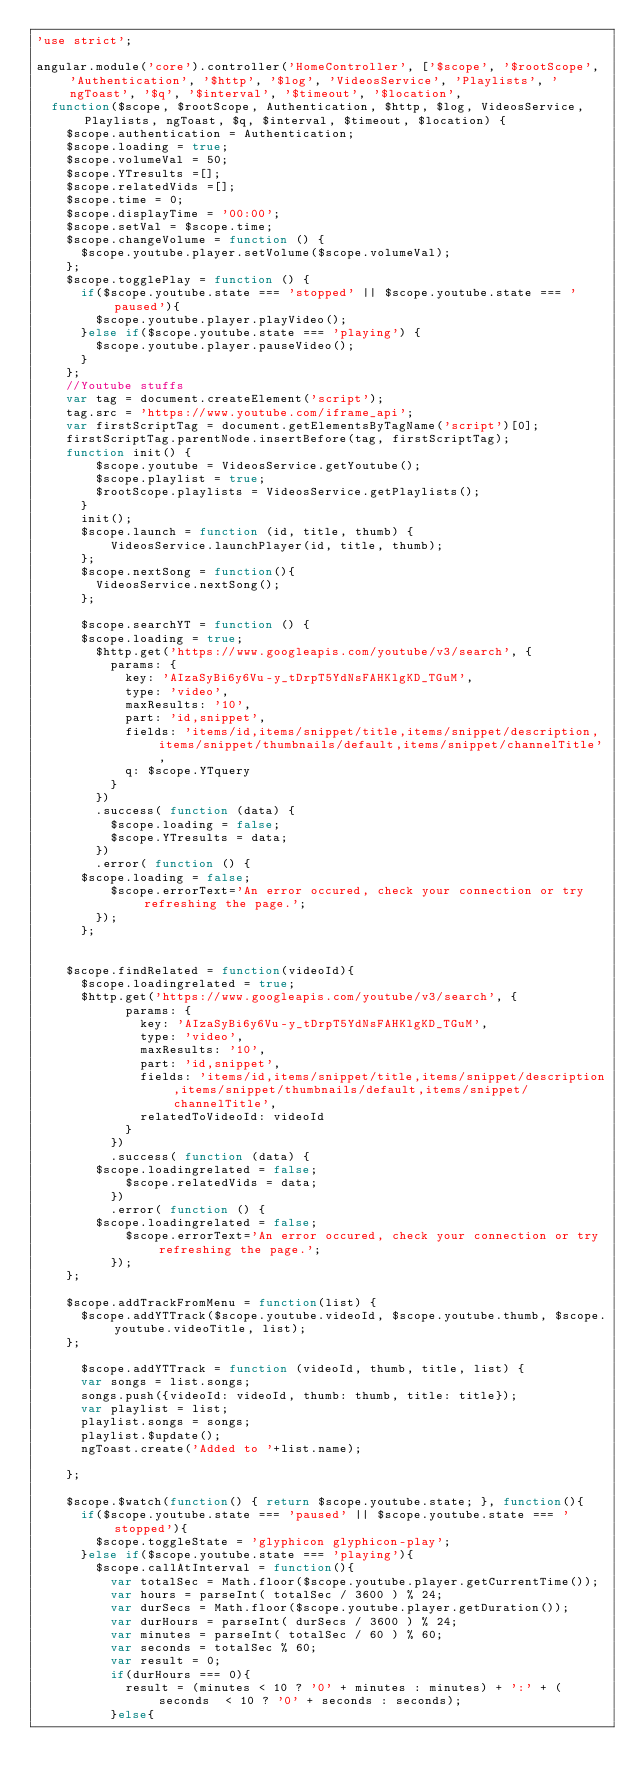<code> <loc_0><loc_0><loc_500><loc_500><_JavaScript_>'use strict';

angular.module('core').controller('HomeController', ['$scope', '$rootScope', 'Authentication', '$http', '$log', 'VideosService', 'Playlists', 'ngToast', '$q', '$interval', '$timeout', '$location',
	function($scope, $rootScope, Authentication, $http, $log, VideosService, Playlists, ngToast, $q, $interval, $timeout, $location) {
		$scope.authentication = Authentication;
		$scope.loading = true;
		$scope.volumeVal = 50;
		$scope.YTresults =[];
		$scope.relatedVids =[];
		$scope.time = 0;
		$scope.displayTime = '00:00';
		$scope.setVal = $scope.time;
		$scope.changeVolume = function () {
			$scope.youtube.player.setVolume($scope.volumeVal);
		};
		$scope.togglePlay = function () {
			if($scope.youtube.state === 'stopped' || $scope.youtube.state === 'paused'){
				$scope.youtube.player.playVideo();
			}else if($scope.youtube.state === 'playing') {
				$scope.youtube.player.pauseVideo();
			}
		};
		//Youtube stuffs
		var tag = document.createElement('script');
		tag.src = 'https://www.youtube.com/iframe_api';
		var firstScriptTag = document.getElementsByTagName('script')[0];
		firstScriptTag.parentNode.insertBefore(tag, firstScriptTag);
		function init() {
	      $scope.youtube = VideosService.getYoutube();
	      $scope.playlist = true;
	      $rootScope.playlists = VideosService.getPlaylists();
	    }
	    init();
	    $scope.launch = function (id, title, thumb) {
	      	VideosService.launchPlayer(id, title, thumb);
	    };
	    $scope.nextSong = function(){
	    	VideosService.nextSong();
	    };

	    $scope.searchYT = function () {
			$scope.loading = true;
	    	$http.get('https://www.googleapis.com/youtube/v3/search', {
	        params: {
	          key: 'AIzaSyBi6y6Vu-y_tDrpT5YdNsFAHKlgKD_TGuM',
	          type: 'video',
	          maxResults: '10',
	          part: 'id,snippet',
	          fields: 'items/id,items/snippet/title,items/snippet/description,items/snippet/thumbnails/default,items/snippet/channelTitle',
	          q: $scope.YTquery
	        }
	      })
	      .success( function (data) {
	      	$scope.loading = false;
	        $scope.YTresults = data;
	      })
	      .error( function () {
			$scope.loading = false;
	        $scope.errorText='An error occured, check your connection or try refreshing the page.';
	      });
	    };


		$scope.findRelated = function(videoId){
			$scope.loadingrelated = true;
			$http.get('https://www.googleapis.com/youtube/v3/search', {
		        params: {
		          key: 'AIzaSyBi6y6Vu-y_tDrpT5YdNsFAHKlgKD_TGuM',
		          type: 'video',
		          maxResults: '10',
		          part: 'id,snippet',
		          fields: 'items/id,items/snippet/title,items/snippet/description,items/snippet/thumbnails/default,items/snippet/channelTitle',
				  		relatedToVideoId: videoId
		        }
		      })
		      .success( function (data) {
				$scope.loadingrelated = false;
		        $scope.relatedVids = data;
		      })
		      .error( function () {
				$scope.loadingrelated = false;
		        $scope.errorText='An error occured, check your connection or try refreshing the page.';
      		});
		};

		$scope.addTrackFromMenu = function(list) {
			$scope.addYTTrack($scope.youtube.videoId, $scope.youtube.thumb, $scope.youtube.videoTitle, list);
		};

	    $scope.addYTTrack = function (videoId, thumb, title, list) {
			var songs = list.songs;
			songs.push({videoId: videoId, thumb: thumb, title: title});
			var playlist = list;
			playlist.songs = songs;
			playlist.$update();
			ngToast.create('Added to '+list.name);

		};

		$scope.$watch(function() { return $scope.youtube.state; }, function(){
			if($scope.youtube.state === 'paused' || $scope.youtube.state === 'stopped'){
				$scope.toggleState = 'glyphicon glyphicon-play';
			}else if($scope.youtube.state === 'playing'){
				$scope.callAtInterval = function(){
					var totalSec = Math.floor($scope.youtube.player.getCurrentTime());
					var hours = parseInt( totalSec / 3600 ) % 24;
					var durSecs = Math.floor($scope.youtube.player.getDuration());
					var durHours = parseInt( durSecs / 3600 ) % 24;
					var minutes = parseInt( totalSec / 60 ) % 60;
					var seconds = totalSec % 60;
					var result = 0;
					if(durHours === 0){
						result = (minutes < 10 ? '0' + minutes : minutes) + ':' + (seconds  < 10 ? '0' + seconds : seconds);
					}else{</code> 